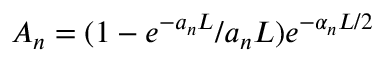Convert formula to latex. <formula><loc_0><loc_0><loc_500><loc_500>A _ { n } = ( 1 - e ^ { - a _ { n } L } / a _ { n } L ) e ^ { - \alpha _ { n } L / 2 }</formula> 